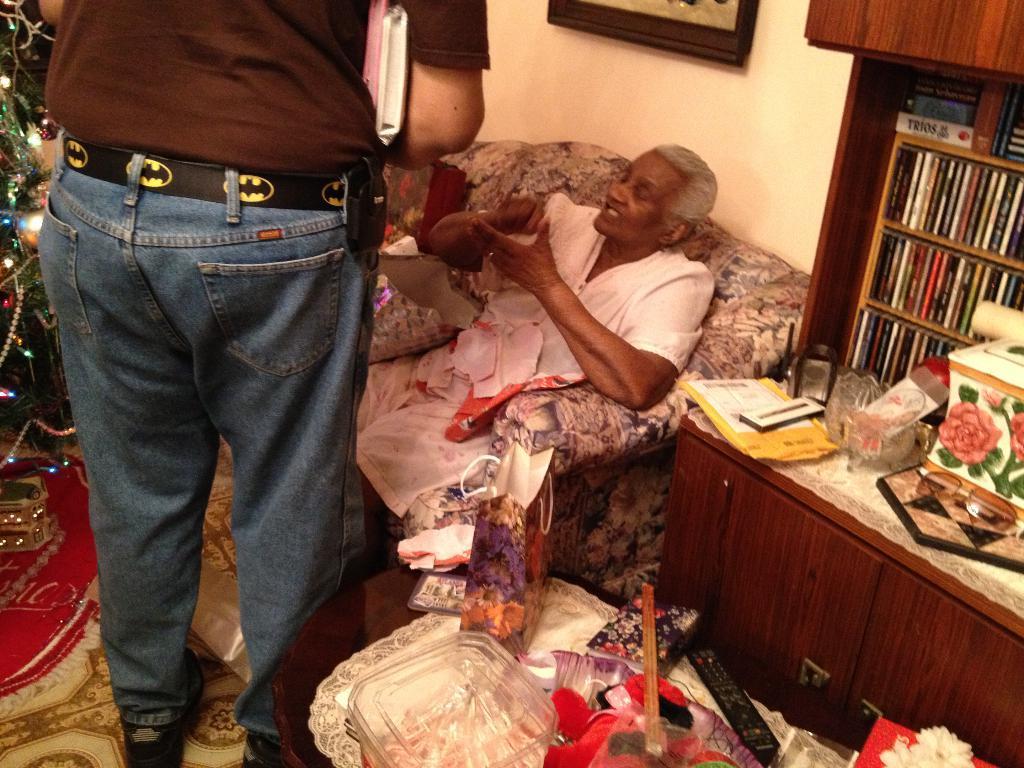Please provide a concise description of this image. This picture is clicked inside the room. In this picture, we see a woman in white dress is sitting on the sofa chair. The man in brown T-shirt is standing. On the left side, we see a Christmas tree which is decorated with the lights. At the bottom of the picture, we see a table on which plastic bag, remote, glass bowl and some other things are placed. On the right side, we see a rack in which many books are placed and a table on which some items are placed. 